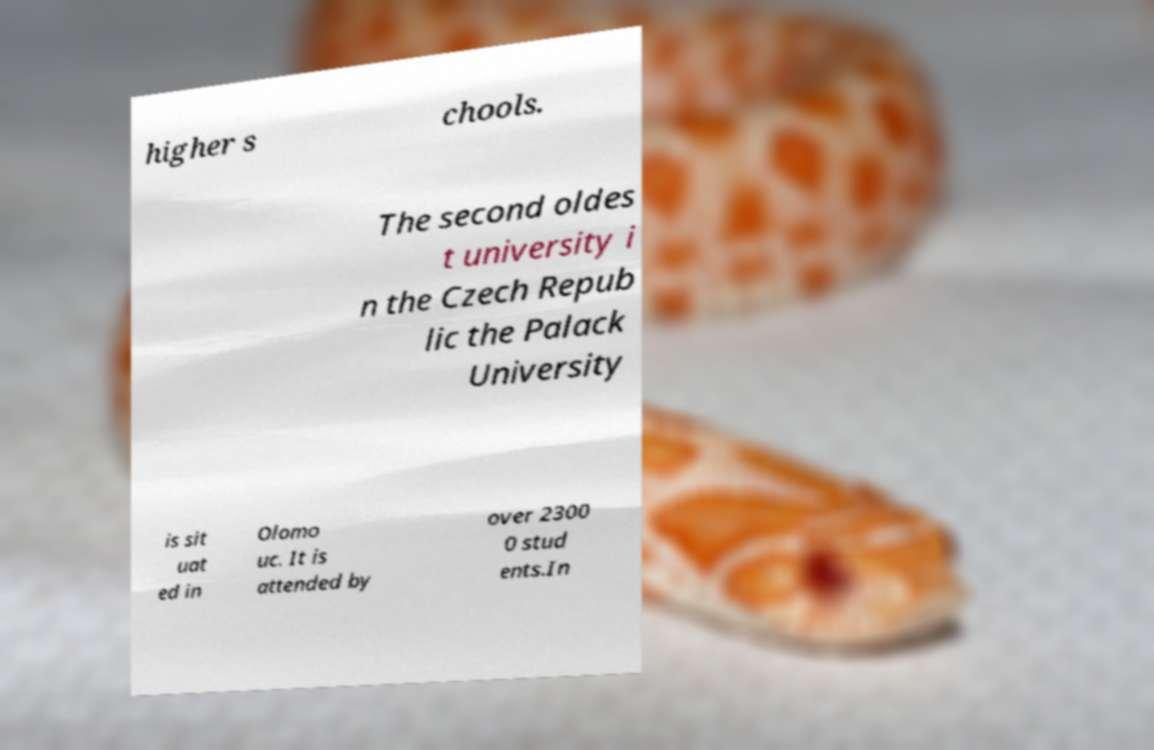Could you assist in decoding the text presented in this image and type it out clearly? higher s chools. The second oldes t university i n the Czech Repub lic the Palack University is sit uat ed in Olomo uc. It is attended by over 2300 0 stud ents.In 